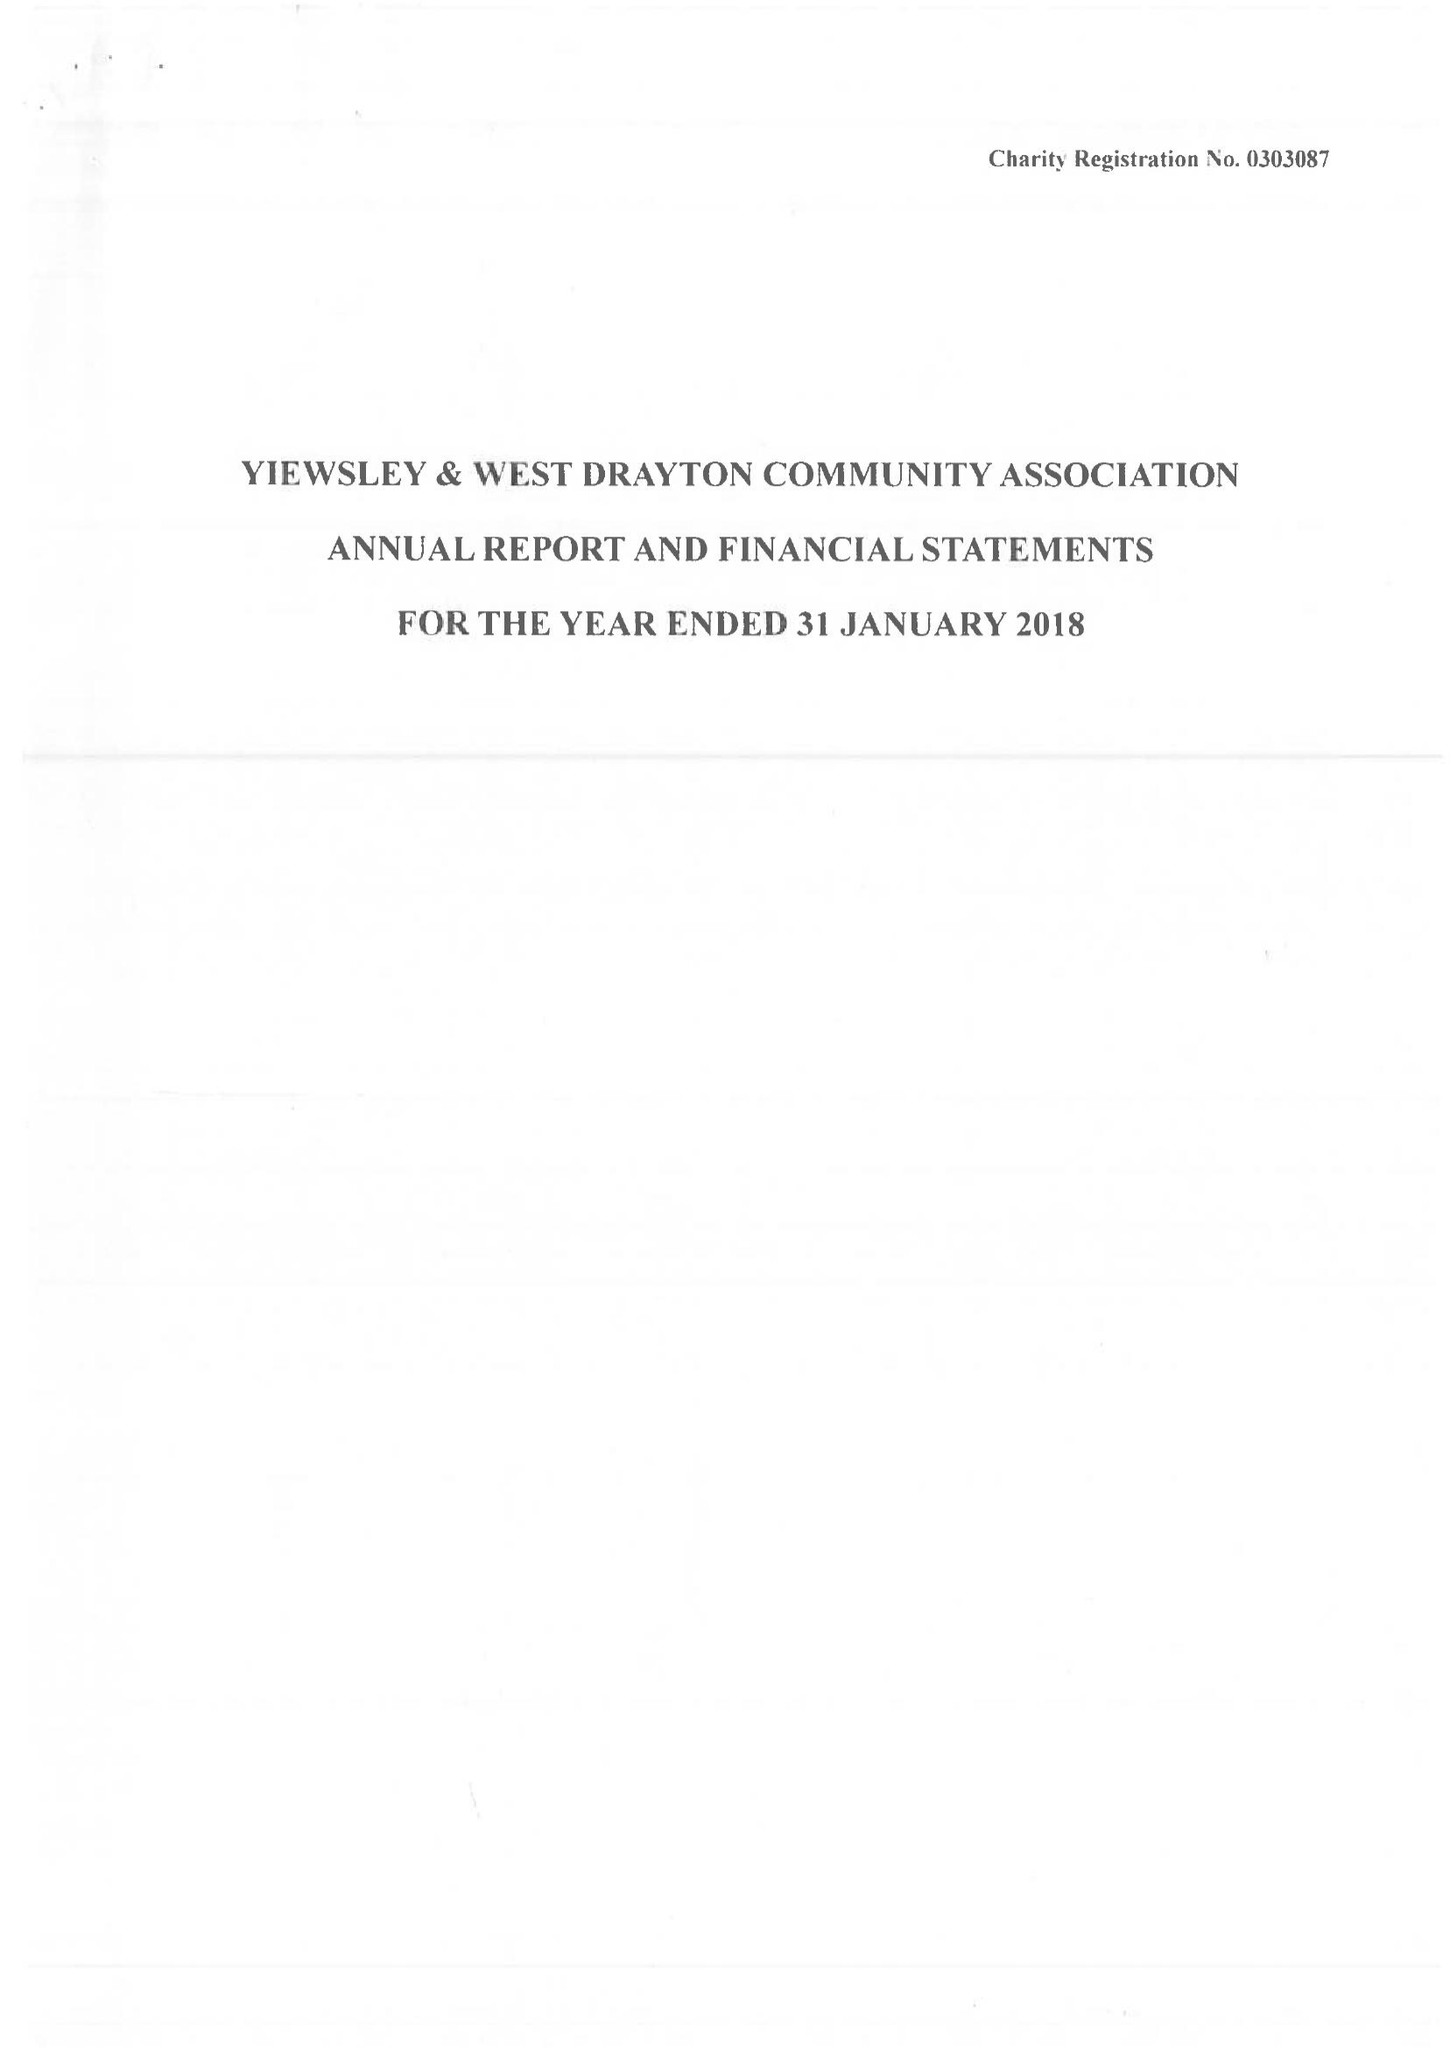What is the value for the charity_name?
Answer the question using a single word or phrase. Yiewsley and West Drayton Community Association 